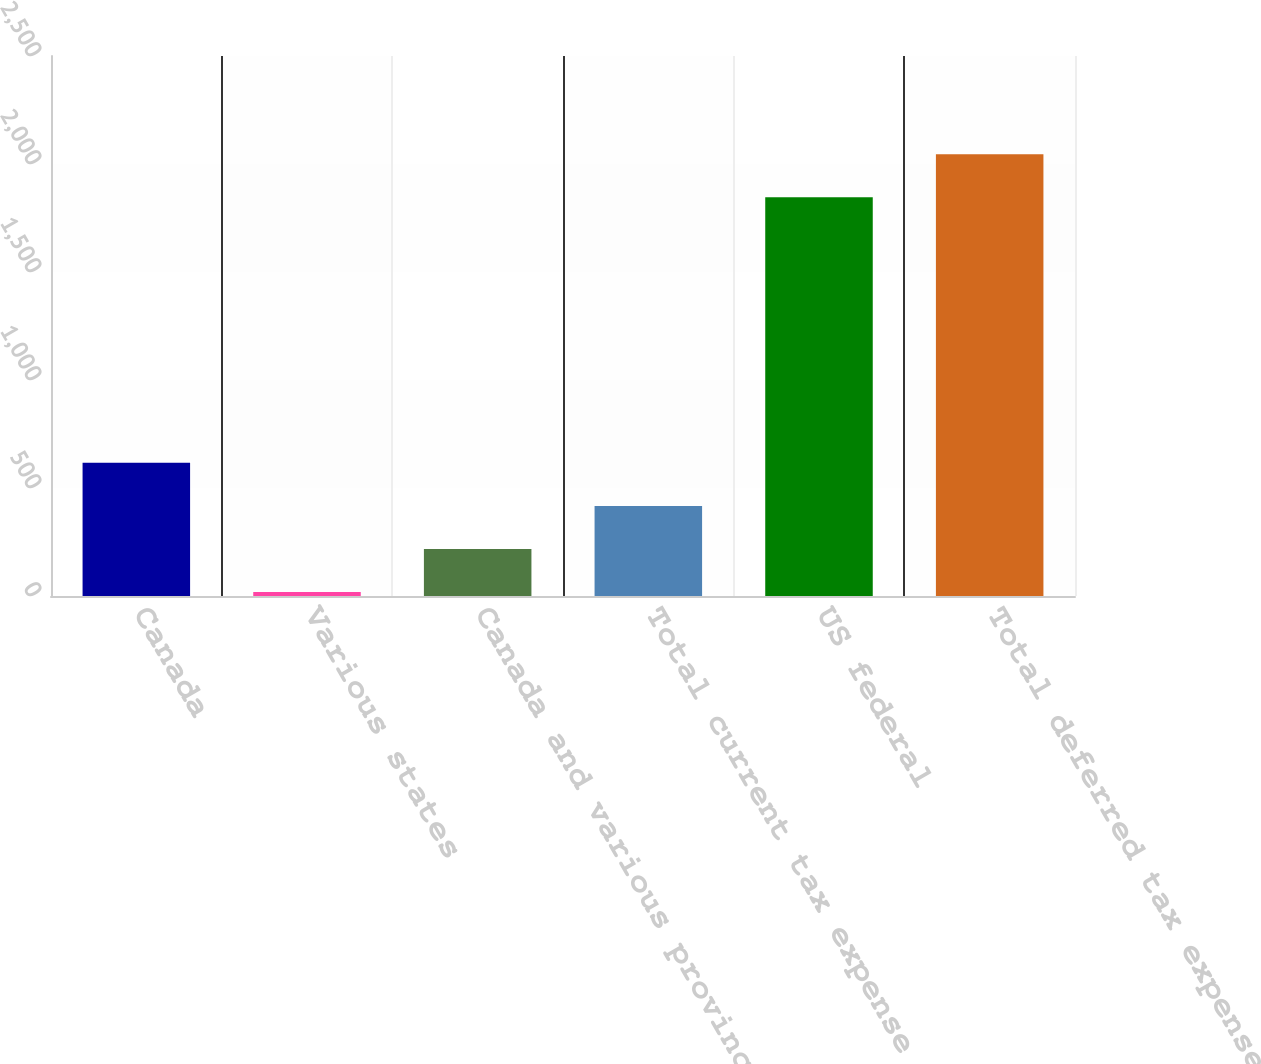<chart> <loc_0><loc_0><loc_500><loc_500><bar_chart><fcel>Canada<fcel>Various states<fcel>Canada and various provinces<fcel>Total current tax expense<fcel>US federal<fcel>Total deferred tax expense<nl><fcel>616.8<fcel>18<fcel>217.6<fcel>417.2<fcel>1846<fcel>2045.6<nl></chart> 